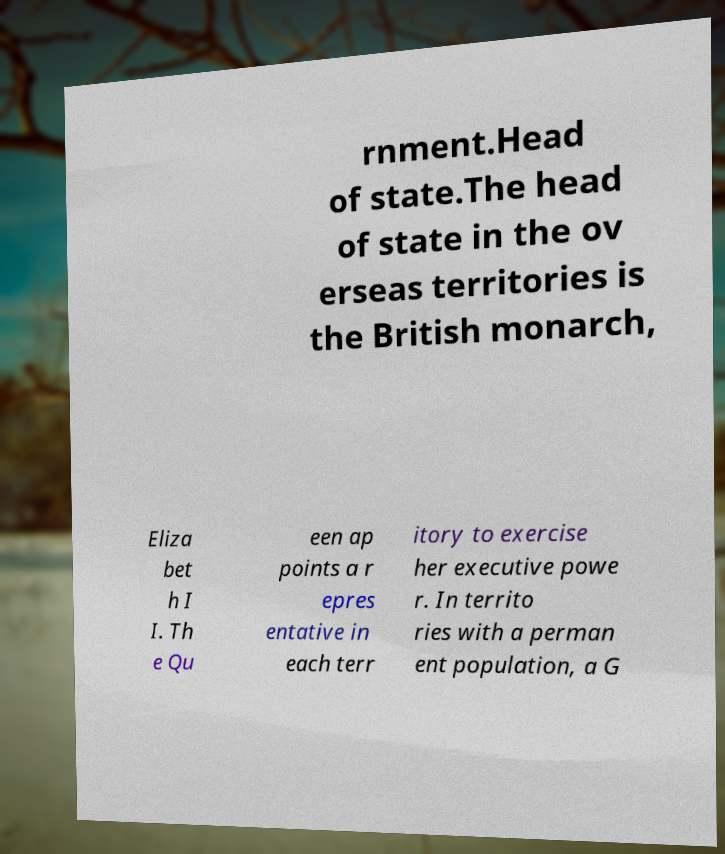Please identify and transcribe the text found in this image. rnment.Head of state.The head of state in the ov erseas territories is the British monarch, Eliza bet h I I. Th e Qu een ap points a r epres entative in each terr itory to exercise her executive powe r. In territo ries with a perman ent population, a G 